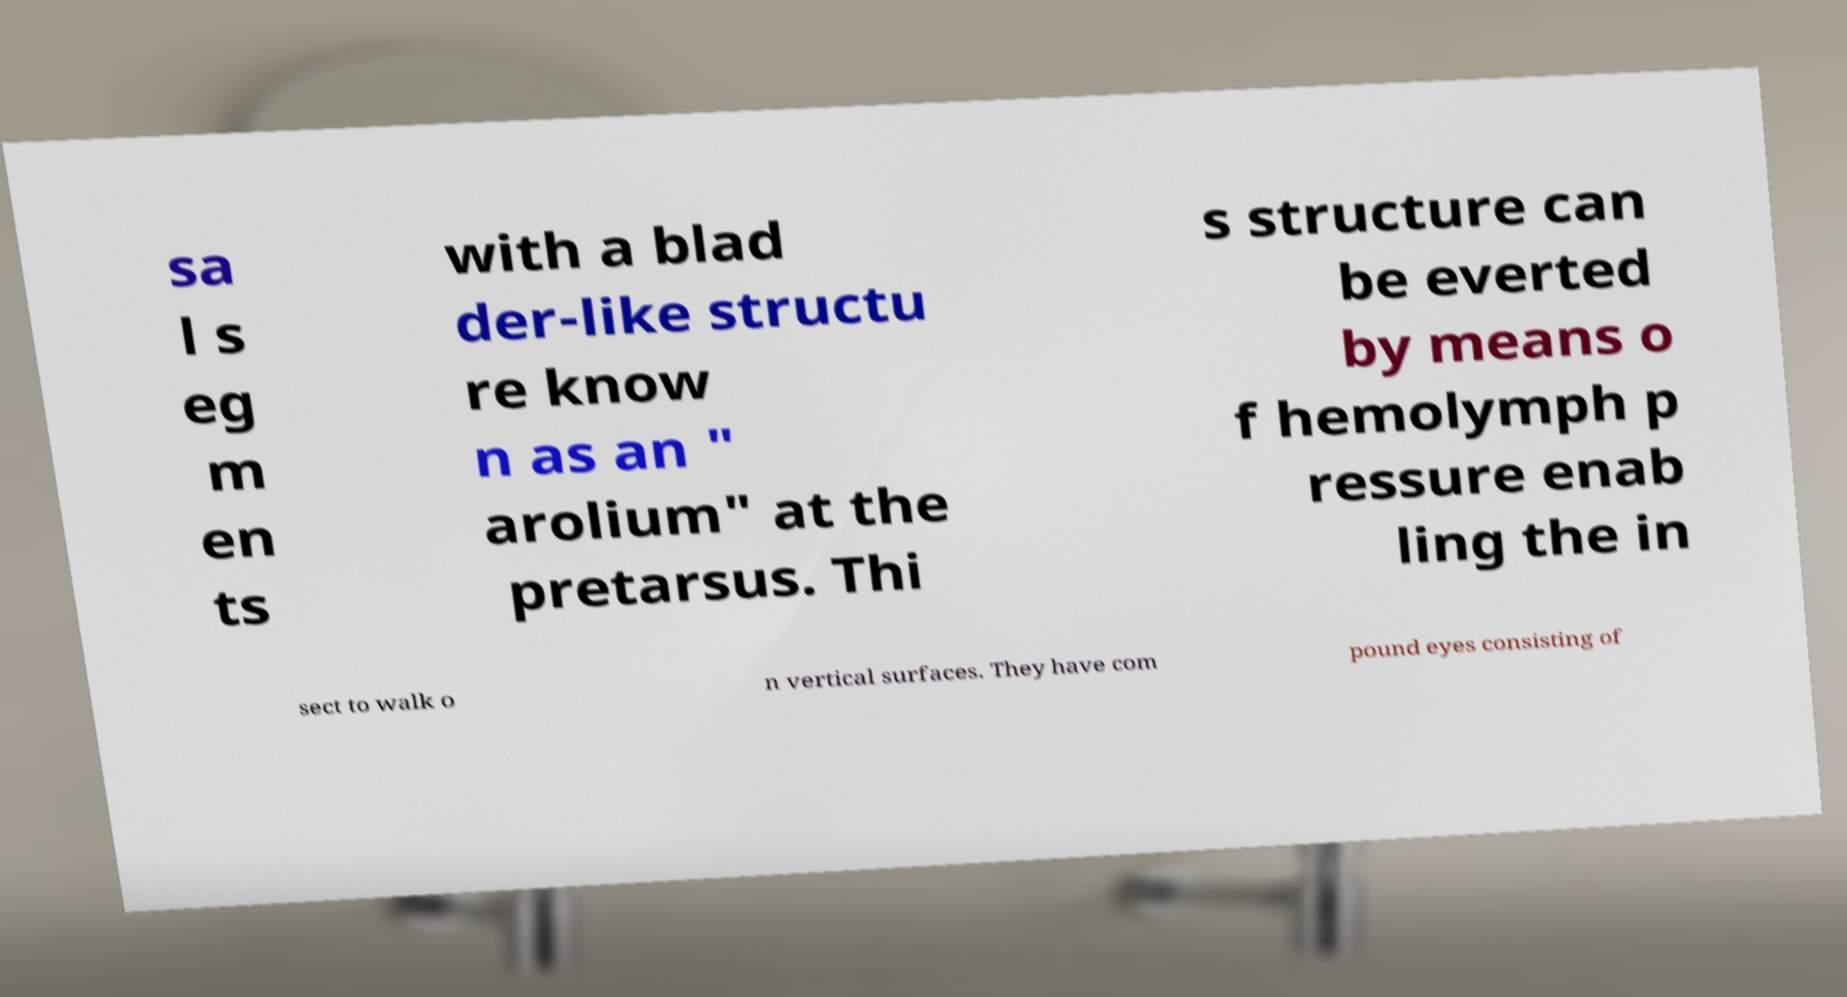Please read and relay the text visible in this image. What does it say? sa l s eg m en ts with a blad der-like structu re know n as an " arolium" at the pretarsus. Thi s structure can be everted by means o f hemolymph p ressure enab ling the in sect to walk o n vertical surfaces. They have com pound eyes consisting of 